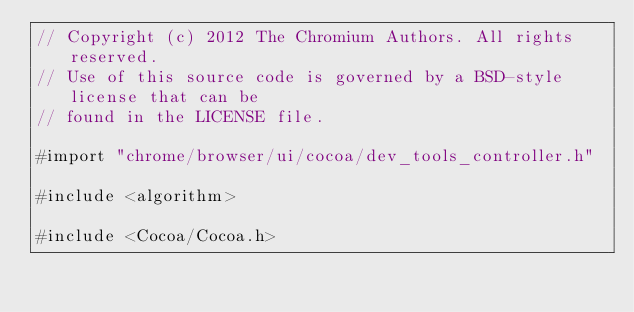<code> <loc_0><loc_0><loc_500><loc_500><_ObjectiveC_>// Copyright (c) 2012 The Chromium Authors. All rights reserved.
// Use of this source code is governed by a BSD-style license that can be
// found in the LICENSE file.

#import "chrome/browser/ui/cocoa/dev_tools_controller.h"

#include <algorithm>

#include <Cocoa/Cocoa.h>
</code> 